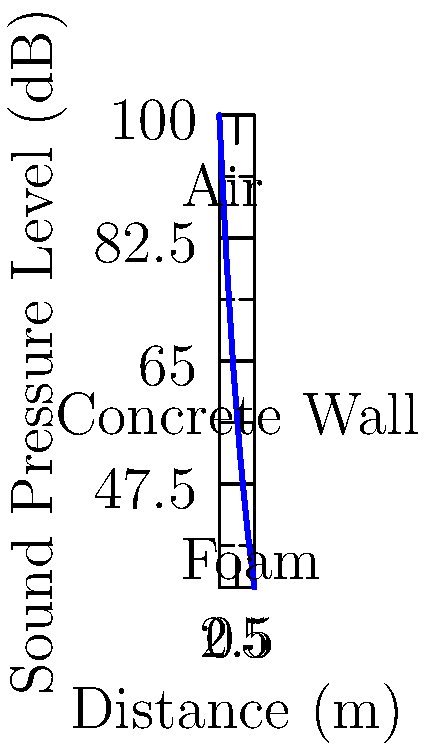A sound wave with an initial sound pressure level of 100 dB propagates through air, then through a concrete wall, and finally through acoustic foam. The graph shows the attenuation of the sound wave over distance. Calculate the total attenuation coefficient ($\alpha$) of the system in dB/m, assuming exponential decay ($SPL = SPL_0 e^{-\alpha x}$). To solve this problem, we'll follow these steps:

1) The exponential decay formula for sound pressure level (SPL) is:
   $SPL = SPL_0 e^{-\alpha x}$

2) We can linearize this equation by taking the natural log of both sides:
   $\ln(SPL) = \ln(SPL_0) - \alpha x$

3) From the graph, we can see:
   Initial SPL ($SPL_0$) = 100 dB
   Final SPL = 32.8 dB
   Total distance (x) = 5 m

4) Plugging these values into our linearized equation:
   $\ln(32.8) = \ln(100) - \alpha (5)$

5) Solving for $\alpha$:
   $\ln(32.8) - \ln(100) = -5\alpha$
   $3.49 - 4.61 = -5\alpha$
   $-1.12 = -5\alpha$

6) Therefore:
   $\alpha = 1.12 / 5 = 0.224$ dB/m

This is the average attenuation coefficient for the entire system, including air, concrete wall, and foam.
Answer: 0.224 dB/m 